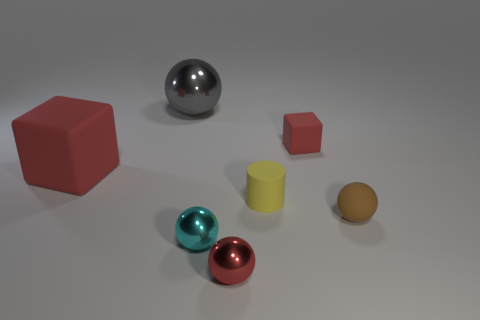Are there any other things that are the same shape as the small yellow matte thing?
Offer a terse response. No. What color is the block that is on the left side of the tiny red thing in front of the cyan sphere?
Offer a terse response. Red. There is a yellow thing that is the same size as the red ball; what is it made of?
Keep it short and to the point. Rubber. How many matte objects are either objects or small yellow cylinders?
Offer a terse response. 4. There is a small matte object that is in front of the tiny block and to the right of the yellow rubber cylinder; what color is it?
Offer a very short reply. Brown. There is a cyan shiny ball; what number of small red objects are in front of it?
Your answer should be very brief. 1. What material is the small block?
Provide a short and direct response. Rubber. The matte thing behind the red rubber cube to the left of the tiny ball in front of the tiny cyan metallic sphere is what color?
Provide a succinct answer. Red. How many red objects are the same size as the brown sphere?
Give a very brief answer. 2. There is a tiny shiny thing that is to the left of the small red shiny sphere; what color is it?
Your response must be concise. Cyan. 